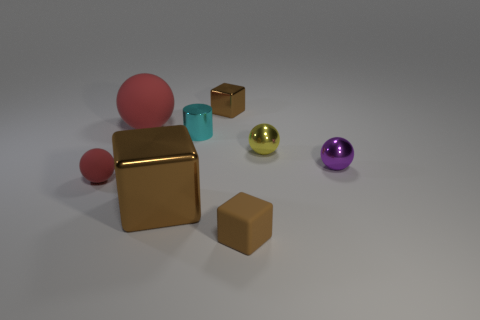Subtract all large brown blocks. How many blocks are left? 2 Subtract all red balls. How many balls are left? 2 Subtract all cubes. How many objects are left? 5 Subtract 3 balls. How many balls are left? 1 Subtract all yellow cubes. Subtract all cyan balls. How many cubes are left? 3 Subtract all yellow cylinders. How many green blocks are left? 0 Subtract all big blue metal cylinders. Subtract all tiny rubber objects. How many objects are left? 6 Add 8 large red spheres. How many large red spheres are left? 9 Add 4 large objects. How many large objects exist? 6 Add 2 tiny blue matte spheres. How many objects exist? 10 